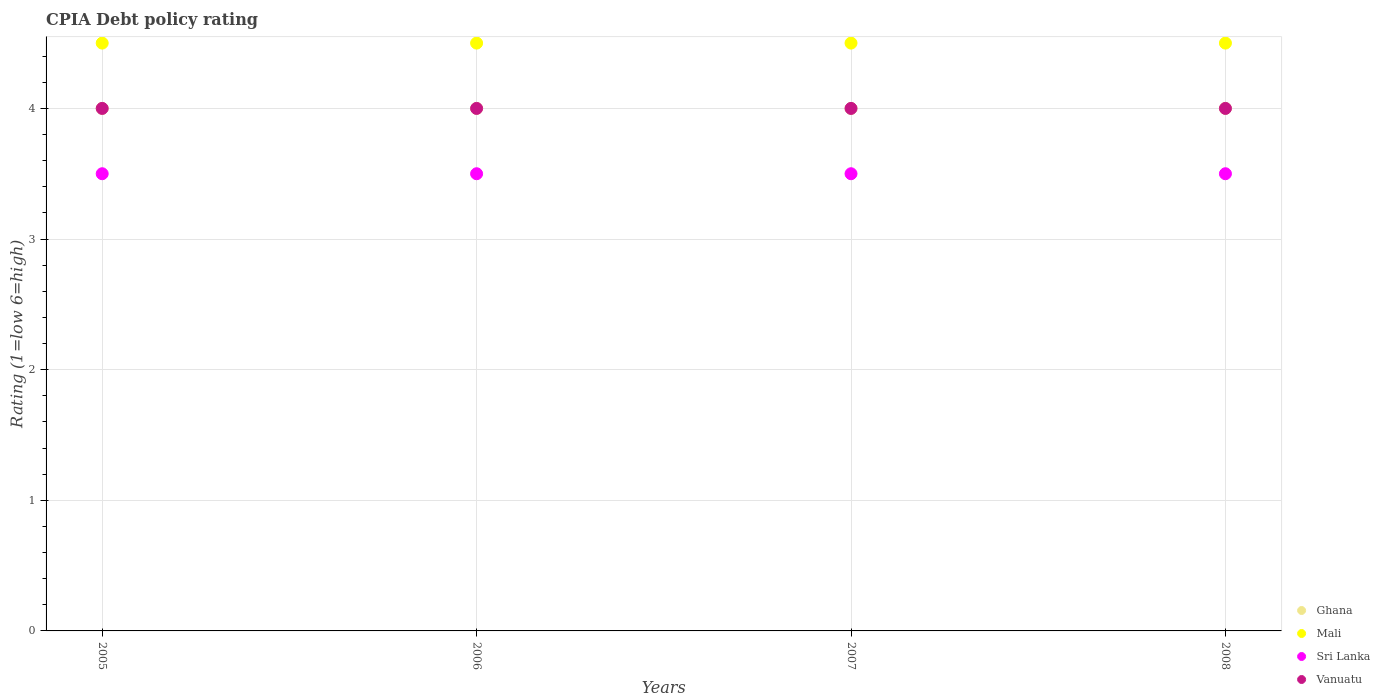Is the number of dotlines equal to the number of legend labels?
Offer a terse response. Yes. Across all years, what is the maximum CPIA rating in Sri Lanka?
Provide a succinct answer. 3.5. Across all years, what is the minimum CPIA rating in Sri Lanka?
Make the answer very short. 3.5. In which year was the CPIA rating in Ghana maximum?
Provide a short and direct response. 2005. In which year was the CPIA rating in Vanuatu minimum?
Keep it short and to the point. 2005. What is the total CPIA rating in Ghana in the graph?
Your response must be concise. 16. What is the difference between the CPIA rating in Vanuatu in 2005 and that in 2006?
Make the answer very short. 0. What is the difference between the CPIA rating in Mali in 2005 and the CPIA rating in Sri Lanka in 2007?
Your answer should be compact. 1. In the year 2008, what is the difference between the CPIA rating in Mali and CPIA rating in Sri Lanka?
Your answer should be very brief. 1. What is the ratio of the CPIA rating in Sri Lanka in 2006 to that in 2007?
Ensure brevity in your answer.  1. What is the difference between the highest and the second highest CPIA rating in Sri Lanka?
Your answer should be very brief. 0. What is the difference between the highest and the lowest CPIA rating in Ghana?
Offer a terse response. 0. In how many years, is the CPIA rating in Ghana greater than the average CPIA rating in Ghana taken over all years?
Your answer should be compact. 0. Is it the case that in every year, the sum of the CPIA rating in Vanuatu and CPIA rating in Mali  is greater than the sum of CPIA rating in Sri Lanka and CPIA rating in Ghana?
Provide a short and direct response. Yes. Is it the case that in every year, the sum of the CPIA rating in Sri Lanka and CPIA rating in Ghana  is greater than the CPIA rating in Vanuatu?
Make the answer very short. Yes. Does the graph contain any zero values?
Ensure brevity in your answer.  No. Does the graph contain grids?
Ensure brevity in your answer.  Yes. What is the title of the graph?
Offer a terse response. CPIA Debt policy rating. What is the label or title of the X-axis?
Your answer should be very brief. Years. What is the Rating (1=low 6=high) in Ghana in 2005?
Provide a succinct answer. 4. What is the Rating (1=low 6=high) in Sri Lanka in 2005?
Provide a short and direct response. 3.5. What is the Rating (1=low 6=high) in Ghana in 2006?
Your answer should be very brief. 4. What is the Rating (1=low 6=high) in Mali in 2006?
Make the answer very short. 4.5. What is the Rating (1=low 6=high) of Vanuatu in 2006?
Give a very brief answer. 4. What is the Rating (1=low 6=high) of Vanuatu in 2007?
Make the answer very short. 4. What is the Rating (1=low 6=high) of Mali in 2008?
Make the answer very short. 4.5. What is the Rating (1=low 6=high) of Sri Lanka in 2008?
Keep it short and to the point. 3.5. What is the Rating (1=low 6=high) in Vanuatu in 2008?
Ensure brevity in your answer.  4. Across all years, what is the maximum Rating (1=low 6=high) in Mali?
Your answer should be compact. 4.5. Across all years, what is the maximum Rating (1=low 6=high) in Sri Lanka?
Provide a short and direct response. 3.5. Across all years, what is the minimum Rating (1=low 6=high) in Mali?
Offer a very short reply. 4.5. What is the difference between the Rating (1=low 6=high) of Mali in 2005 and that in 2006?
Your response must be concise. 0. What is the difference between the Rating (1=low 6=high) of Vanuatu in 2005 and that in 2006?
Give a very brief answer. 0. What is the difference between the Rating (1=low 6=high) in Mali in 2005 and that in 2007?
Give a very brief answer. 0. What is the difference between the Rating (1=low 6=high) of Vanuatu in 2005 and that in 2007?
Your answer should be very brief. 0. What is the difference between the Rating (1=low 6=high) of Ghana in 2005 and that in 2008?
Ensure brevity in your answer.  0. What is the difference between the Rating (1=low 6=high) of Mali in 2005 and that in 2008?
Provide a succinct answer. 0. What is the difference between the Rating (1=low 6=high) in Vanuatu in 2005 and that in 2008?
Offer a terse response. 0. What is the difference between the Rating (1=low 6=high) of Ghana in 2006 and that in 2007?
Offer a very short reply. 0. What is the difference between the Rating (1=low 6=high) of Sri Lanka in 2006 and that in 2007?
Make the answer very short. 0. What is the difference between the Rating (1=low 6=high) in Vanuatu in 2006 and that in 2007?
Offer a terse response. 0. What is the difference between the Rating (1=low 6=high) in Vanuatu in 2006 and that in 2008?
Your answer should be compact. 0. What is the difference between the Rating (1=low 6=high) in Ghana in 2007 and that in 2008?
Offer a very short reply. 0. What is the difference between the Rating (1=low 6=high) of Mali in 2007 and that in 2008?
Keep it short and to the point. 0. What is the difference between the Rating (1=low 6=high) of Sri Lanka in 2007 and that in 2008?
Your answer should be compact. 0. What is the difference between the Rating (1=low 6=high) in Ghana in 2005 and the Rating (1=low 6=high) in Mali in 2006?
Give a very brief answer. -0.5. What is the difference between the Rating (1=low 6=high) of Ghana in 2005 and the Rating (1=low 6=high) of Sri Lanka in 2006?
Offer a very short reply. 0.5. What is the difference between the Rating (1=low 6=high) of Sri Lanka in 2005 and the Rating (1=low 6=high) of Vanuatu in 2006?
Your answer should be very brief. -0.5. What is the difference between the Rating (1=low 6=high) of Ghana in 2005 and the Rating (1=low 6=high) of Mali in 2007?
Keep it short and to the point. -0.5. What is the difference between the Rating (1=low 6=high) in Ghana in 2005 and the Rating (1=low 6=high) in Sri Lanka in 2007?
Offer a very short reply. 0.5. What is the difference between the Rating (1=low 6=high) in Mali in 2005 and the Rating (1=low 6=high) in Vanuatu in 2007?
Keep it short and to the point. 0.5. What is the difference between the Rating (1=low 6=high) in Ghana in 2005 and the Rating (1=low 6=high) in Sri Lanka in 2008?
Give a very brief answer. 0.5. What is the difference between the Rating (1=low 6=high) of Mali in 2005 and the Rating (1=low 6=high) of Sri Lanka in 2008?
Offer a terse response. 1. What is the difference between the Rating (1=low 6=high) of Mali in 2005 and the Rating (1=low 6=high) of Vanuatu in 2008?
Keep it short and to the point. 0.5. What is the difference between the Rating (1=low 6=high) of Ghana in 2006 and the Rating (1=low 6=high) of Vanuatu in 2007?
Your answer should be very brief. 0. What is the difference between the Rating (1=low 6=high) in Sri Lanka in 2006 and the Rating (1=low 6=high) in Vanuatu in 2007?
Your answer should be very brief. -0.5. What is the difference between the Rating (1=low 6=high) in Ghana in 2006 and the Rating (1=low 6=high) in Sri Lanka in 2008?
Provide a short and direct response. 0.5. What is the difference between the Rating (1=low 6=high) in Sri Lanka in 2006 and the Rating (1=low 6=high) in Vanuatu in 2008?
Your answer should be very brief. -0.5. What is the difference between the Rating (1=low 6=high) in Mali in 2007 and the Rating (1=low 6=high) in Sri Lanka in 2008?
Ensure brevity in your answer.  1. What is the difference between the Rating (1=low 6=high) in Mali in 2007 and the Rating (1=low 6=high) in Vanuatu in 2008?
Your answer should be very brief. 0.5. What is the difference between the Rating (1=low 6=high) in Sri Lanka in 2007 and the Rating (1=low 6=high) in Vanuatu in 2008?
Provide a short and direct response. -0.5. What is the average Rating (1=low 6=high) in Sri Lanka per year?
Make the answer very short. 3.5. In the year 2005, what is the difference between the Rating (1=low 6=high) of Ghana and Rating (1=low 6=high) of Sri Lanka?
Provide a succinct answer. 0.5. In the year 2005, what is the difference between the Rating (1=low 6=high) in Mali and Rating (1=low 6=high) in Sri Lanka?
Provide a short and direct response. 1. In the year 2005, what is the difference between the Rating (1=low 6=high) in Mali and Rating (1=low 6=high) in Vanuatu?
Your answer should be very brief. 0.5. In the year 2006, what is the difference between the Rating (1=low 6=high) in Ghana and Rating (1=low 6=high) in Mali?
Your answer should be very brief. -0.5. In the year 2006, what is the difference between the Rating (1=low 6=high) in Mali and Rating (1=low 6=high) in Sri Lanka?
Give a very brief answer. 1. In the year 2006, what is the difference between the Rating (1=low 6=high) in Sri Lanka and Rating (1=low 6=high) in Vanuatu?
Provide a succinct answer. -0.5. In the year 2007, what is the difference between the Rating (1=low 6=high) in Ghana and Rating (1=low 6=high) in Mali?
Your answer should be very brief. -0.5. In the year 2007, what is the difference between the Rating (1=low 6=high) of Ghana and Rating (1=low 6=high) of Sri Lanka?
Your response must be concise. 0.5. In the year 2007, what is the difference between the Rating (1=low 6=high) of Mali and Rating (1=low 6=high) of Vanuatu?
Offer a terse response. 0.5. In the year 2007, what is the difference between the Rating (1=low 6=high) of Sri Lanka and Rating (1=low 6=high) of Vanuatu?
Your answer should be very brief. -0.5. In the year 2008, what is the difference between the Rating (1=low 6=high) of Ghana and Rating (1=low 6=high) of Mali?
Your answer should be very brief. -0.5. In the year 2008, what is the difference between the Rating (1=low 6=high) in Ghana and Rating (1=low 6=high) in Sri Lanka?
Your answer should be very brief. 0.5. What is the ratio of the Rating (1=low 6=high) in Mali in 2005 to that in 2006?
Ensure brevity in your answer.  1. What is the ratio of the Rating (1=low 6=high) in Vanuatu in 2005 to that in 2006?
Provide a succinct answer. 1. What is the ratio of the Rating (1=low 6=high) of Vanuatu in 2005 to that in 2007?
Your answer should be very brief. 1. What is the ratio of the Rating (1=low 6=high) in Ghana in 2005 to that in 2008?
Give a very brief answer. 1. What is the ratio of the Rating (1=low 6=high) of Mali in 2005 to that in 2008?
Offer a terse response. 1. What is the ratio of the Rating (1=low 6=high) of Sri Lanka in 2005 to that in 2008?
Your answer should be compact. 1. What is the ratio of the Rating (1=low 6=high) of Vanuatu in 2005 to that in 2008?
Keep it short and to the point. 1. What is the ratio of the Rating (1=low 6=high) of Ghana in 2006 to that in 2007?
Your answer should be very brief. 1. What is the ratio of the Rating (1=low 6=high) of Ghana in 2006 to that in 2008?
Offer a terse response. 1. What is the difference between the highest and the second highest Rating (1=low 6=high) of Mali?
Your answer should be very brief. 0. What is the difference between the highest and the second highest Rating (1=low 6=high) of Sri Lanka?
Offer a terse response. 0. What is the difference between the highest and the second highest Rating (1=low 6=high) in Vanuatu?
Give a very brief answer. 0. What is the difference between the highest and the lowest Rating (1=low 6=high) in Mali?
Your answer should be compact. 0. 